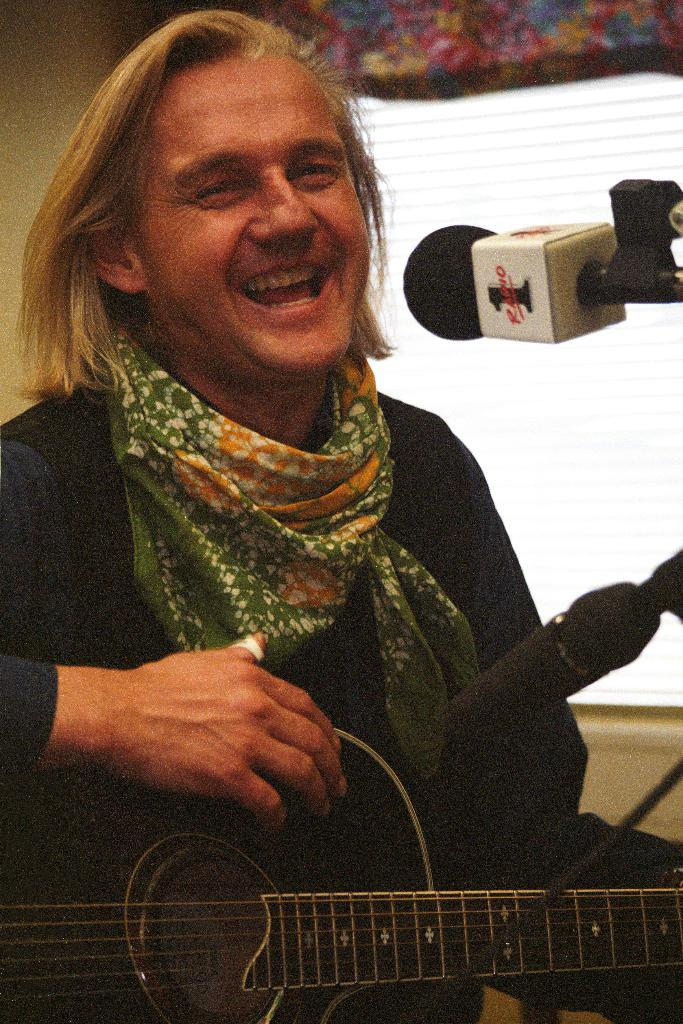What is the person in the image doing? The person is holding a guitar. How does the person appear to be feeling in the image? The person has a smile on their face, indicating they are happy or enjoying themselves. What object is in front of the person? There is a microphone in front of the person. What type of food is the person eating in the image? There is no food present in the image; the person is holding a guitar and standing near a microphone. 